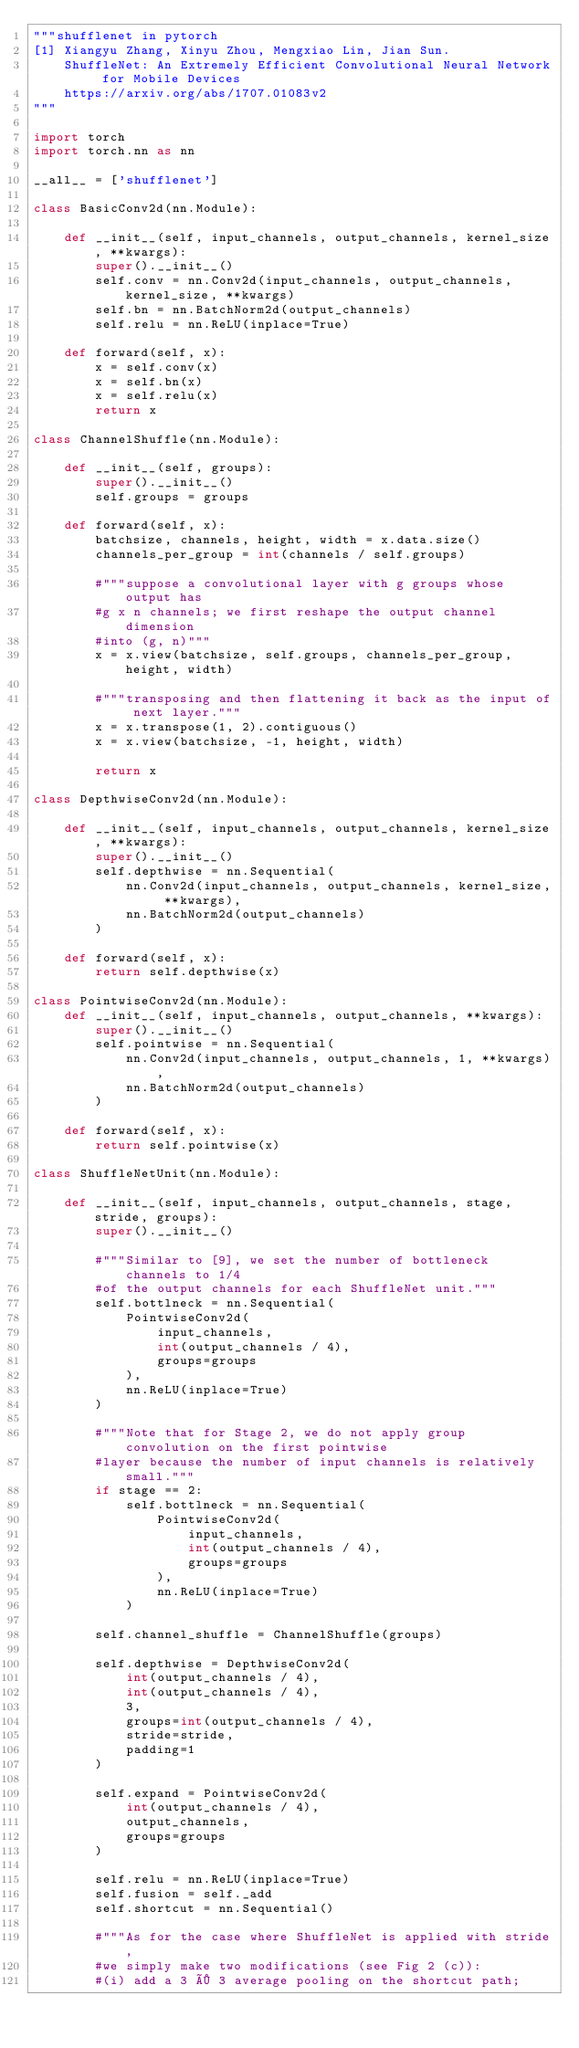<code> <loc_0><loc_0><loc_500><loc_500><_Python_>"""shufflenet in pytorch
[1] Xiangyu Zhang, Xinyu Zhou, Mengxiao Lin, Jian Sun.
    ShuffleNet: An Extremely Efficient Convolutional Neural Network for Mobile Devices
    https://arxiv.org/abs/1707.01083v2
"""

import torch
import torch.nn as nn

__all__ = ['shufflenet']

class BasicConv2d(nn.Module):

    def __init__(self, input_channels, output_channels, kernel_size, **kwargs):
        super().__init__()
        self.conv = nn.Conv2d(input_channels, output_channels, kernel_size, **kwargs)
        self.bn = nn.BatchNorm2d(output_channels)
        self.relu = nn.ReLU(inplace=True)

    def forward(self, x):
        x = self.conv(x)
        x = self.bn(x)
        x = self.relu(x)
        return x

class ChannelShuffle(nn.Module):

    def __init__(self, groups):
        super().__init__()
        self.groups = groups

    def forward(self, x):
        batchsize, channels, height, width = x.data.size()
        channels_per_group = int(channels / self.groups)

        #"""suppose a convolutional layer with g groups whose output has
        #g x n channels; we first reshape the output channel dimension
        #into (g, n)"""
        x = x.view(batchsize, self.groups, channels_per_group, height, width)

        #"""transposing and then flattening it back as the input of next layer."""
        x = x.transpose(1, 2).contiguous()
        x = x.view(batchsize, -1, height, width)

        return x

class DepthwiseConv2d(nn.Module):

    def __init__(self, input_channels, output_channels, kernel_size, **kwargs):
        super().__init__()
        self.depthwise = nn.Sequential(
            nn.Conv2d(input_channels, output_channels, kernel_size, **kwargs),
            nn.BatchNorm2d(output_channels)
        )

    def forward(self, x):
        return self.depthwise(x)

class PointwiseConv2d(nn.Module):
    def __init__(self, input_channels, output_channels, **kwargs):
        super().__init__()
        self.pointwise = nn.Sequential(
            nn.Conv2d(input_channels, output_channels, 1, **kwargs),
            nn.BatchNorm2d(output_channels)
        )

    def forward(self, x):
        return self.pointwise(x)

class ShuffleNetUnit(nn.Module):

    def __init__(self, input_channels, output_channels, stage, stride, groups):
        super().__init__()

        #"""Similar to [9], we set the number of bottleneck channels to 1/4
        #of the output channels for each ShuffleNet unit."""
        self.bottlneck = nn.Sequential(
            PointwiseConv2d(
                input_channels,
                int(output_channels / 4),
                groups=groups
            ),
            nn.ReLU(inplace=True)
        )

        #"""Note that for Stage 2, we do not apply group convolution on the first pointwise
        #layer because the number of input channels is relatively small."""
        if stage == 2:
            self.bottlneck = nn.Sequential(
                PointwiseConv2d(
                    input_channels,
                    int(output_channels / 4),
                    groups=groups
                ),
                nn.ReLU(inplace=True)
            )

        self.channel_shuffle = ChannelShuffle(groups)

        self.depthwise = DepthwiseConv2d(
            int(output_channels / 4),
            int(output_channels / 4),
            3,
            groups=int(output_channels / 4),
            stride=stride,
            padding=1
        )

        self.expand = PointwiseConv2d(
            int(output_channels / 4),
            output_channels,
            groups=groups
        )

        self.relu = nn.ReLU(inplace=True)
        self.fusion = self._add
        self.shortcut = nn.Sequential()

        #"""As for the case where ShuffleNet is applied with stride,
        #we simply make two modifications (see Fig 2 (c)):
        #(i) add a 3 × 3 average pooling on the shortcut path;</code> 